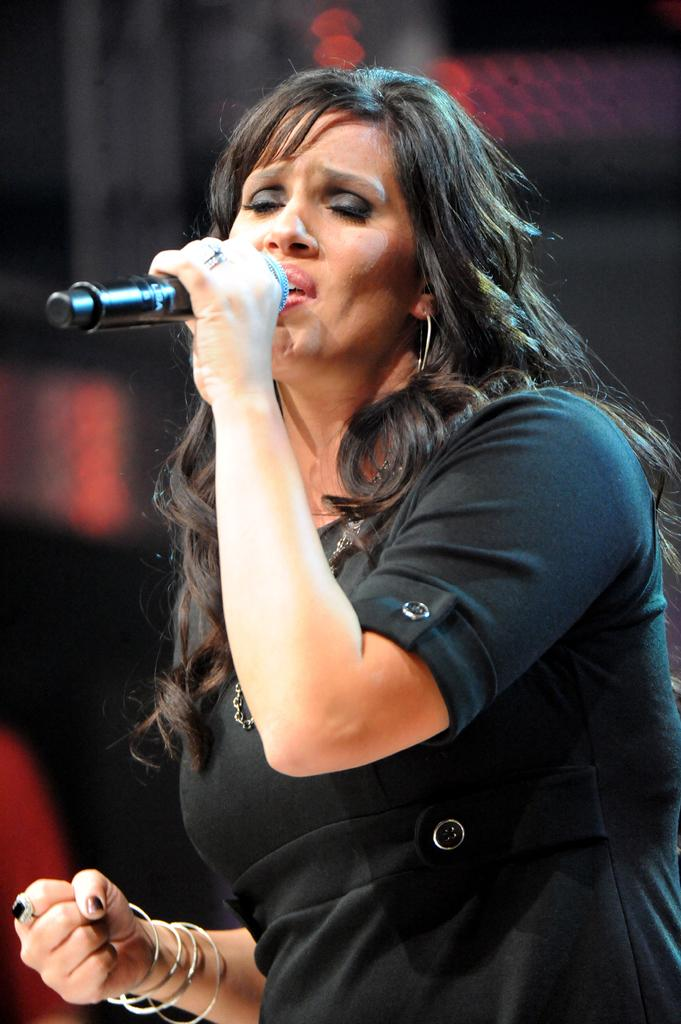Who is the main subject in the image? There is a woman in the image. What is the woman wearing? The woman is wearing a dress. What is the woman holding in the image? The woman is holding a microphone. What can be seen in the background of the image? There are lights visible in the background of the image. What type of stew is being prepared in the image? There is no stew present in the image; it features a woman holding a microphone. How many frames are visible in the image? The image is a single frame, so there is only one frame visible. 